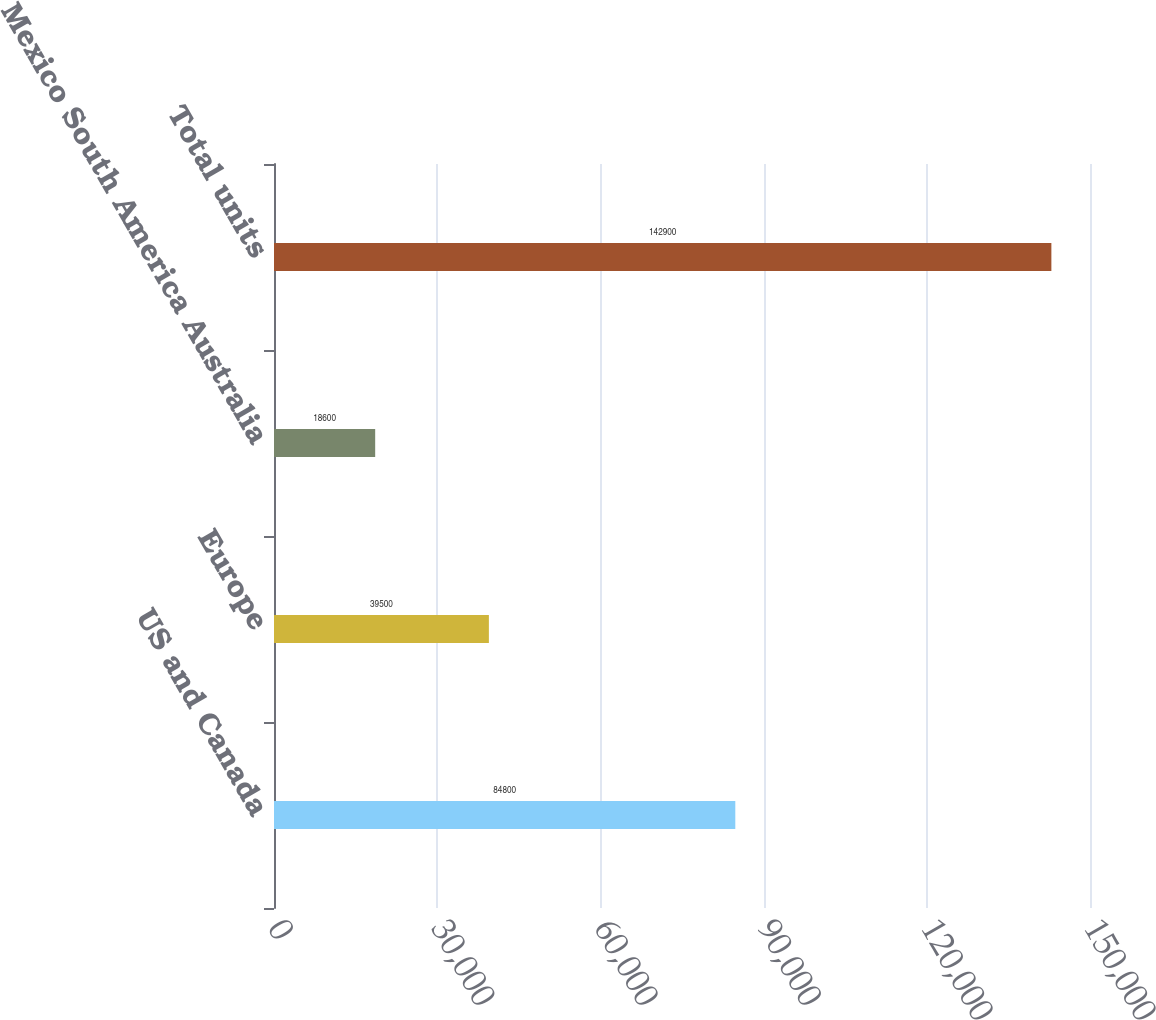Convert chart to OTSL. <chart><loc_0><loc_0><loc_500><loc_500><bar_chart><fcel>US and Canada<fcel>Europe<fcel>Mexico South America Australia<fcel>Total units<nl><fcel>84800<fcel>39500<fcel>18600<fcel>142900<nl></chart> 